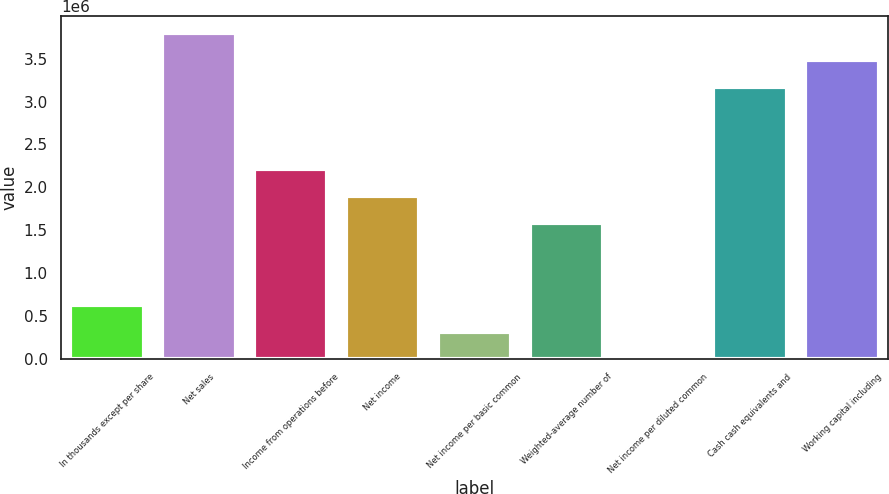Convert chart to OTSL. <chart><loc_0><loc_0><loc_500><loc_500><bar_chart><fcel>In thousands except per share<fcel>Net sales<fcel>Income from operations before<fcel>Net income<fcel>Net income per basic common<fcel>Weighted-average number of<fcel>Net income per diluted common<fcel>Cash cash equivalents and<fcel>Working capital including<nl><fcel>633634<fcel>3.80178e+06<fcel>2.21771e+06<fcel>1.90089e+06<fcel>316820<fcel>1.58408e+06<fcel>5.19<fcel>3.16815e+06<fcel>3.48496e+06<nl></chart> 